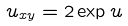Convert formula to latex. <formula><loc_0><loc_0><loc_500><loc_500>u _ { x y } = 2 \exp u</formula> 